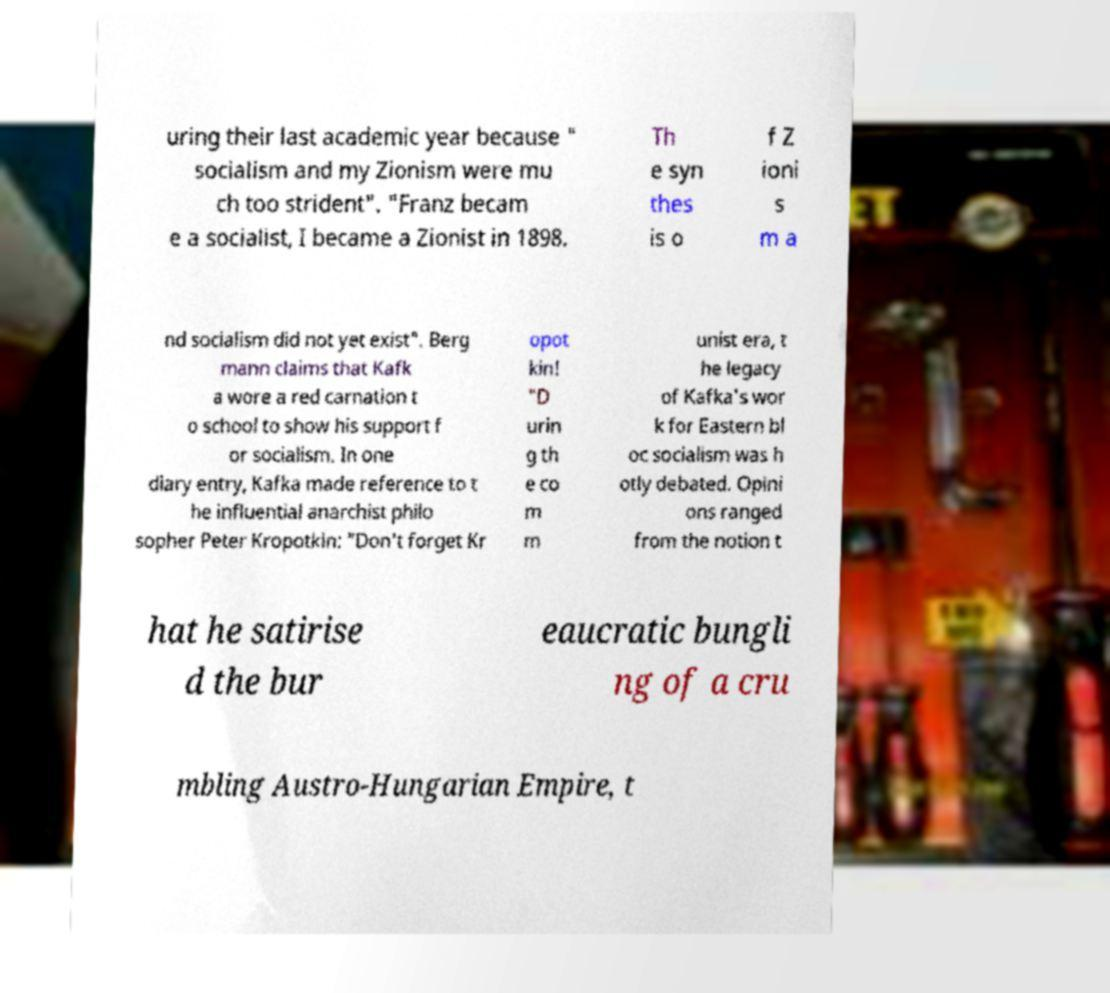Please read and relay the text visible in this image. What does it say? uring their last academic year because " socialism and my Zionism were mu ch too strident". "Franz becam e a socialist, I became a Zionist in 1898. Th e syn thes is o f Z ioni s m a nd socialism did not yet exist". Berg mann claims that Kafk a wore a red carnation t o school to show his support f or socialism. In one diary entry, Kafka made reference to t he influential anarchist philo sopher Peter Kropotkin: "Don't forget Kr opot kin! "D urin g th e co m m unist era, t he legacy of Kafka's wor k for Eastern bl oc socialism was h otly debated. Opini ons ranged from the notion t hat he satirise d the bur eaucratic bungli ng of a cru mbling Austro-Hungarian Empire, t 